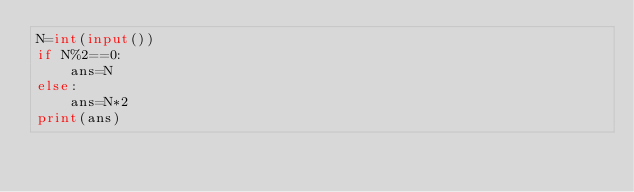Convert code to text. <code><loc_0><loc_0><loc_500><loc_500><_Python_>N=int(input())
if N%2==0:
    ans=N
else:
    ans=N*2
print(ans)
</code> 